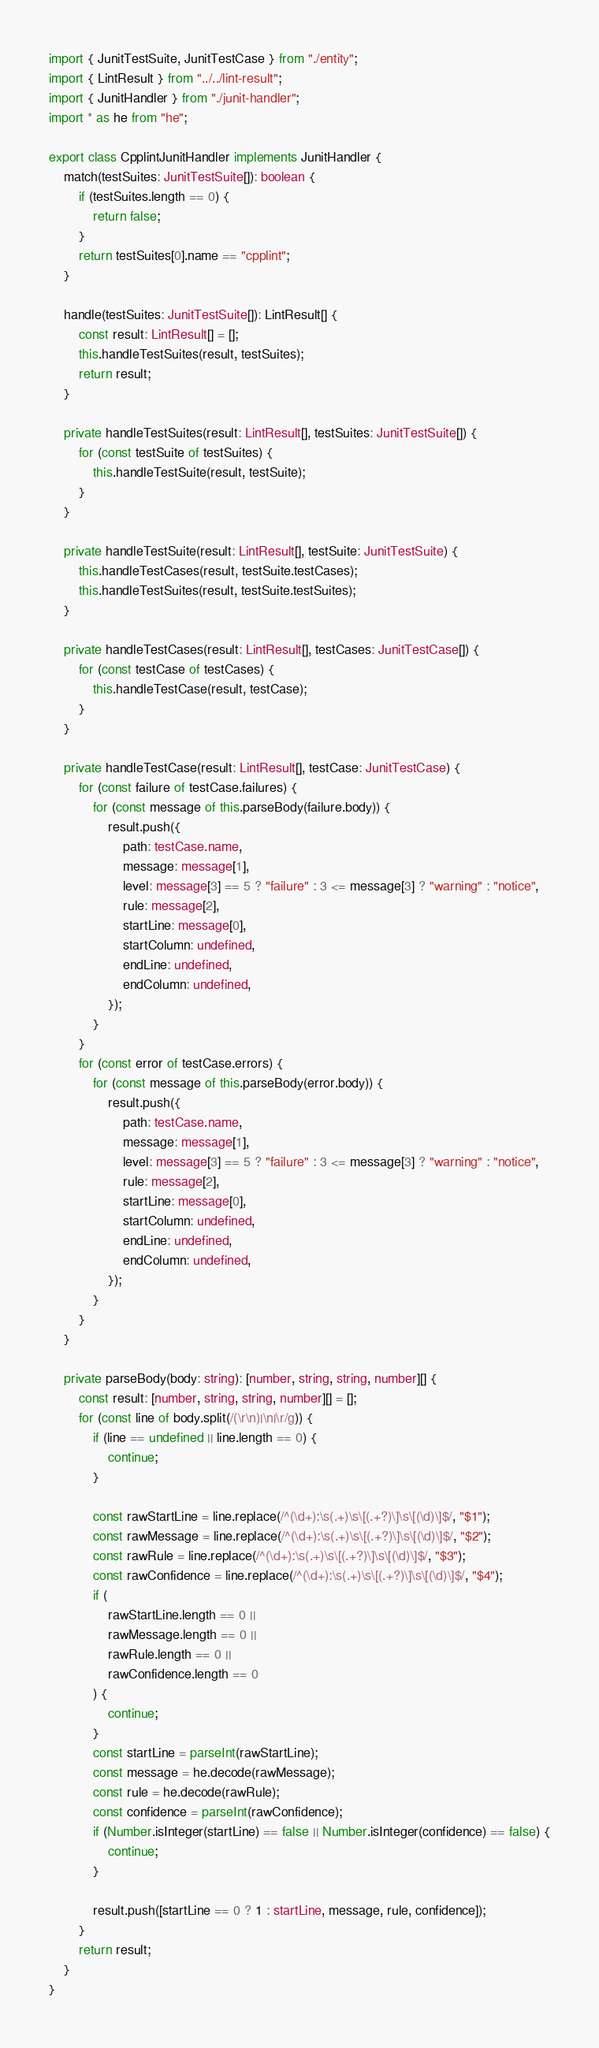Convert code to text. <code><loc_0><loc_0><loc_500><loc_500><_TypeScript_>import { JunitTestSuite, JunitTestCase } from "./entity";
import { LintResult } from "../../lint-result";
import { JunitHandler } from "./junit-handler";
import * as he from "he";

export class CpplintJunitHandler implements JunitHandler {
    match(testSuites: JunitTestSuite[]): boolean {
        if (testSuites.length == 0) {
            return false;
        }
        return testSuites[0].name == "cpplint";
    }

    handle(testSuites: JunitTestSuite[]): LintResult[] {
        const result: LintResult[] = [];
        this.handleTestSuites(result, testSuites);
        return result;
    }

    private handleTestSuites(result: LintResult[], testSuites: JunitTestSuite[]) {
        for (const testSuite of testSuites) {
            this.handleTestSuite(result, testSuite);
        }
    }

    private handleTestSuite(result: LintResult[], testSuite: JunitTestSuite) {
        this.handleTestCases(result, testSuite.testCases);
        this.handleTestSuites(result, testSuite.testSuites);
    }

    private handleTestCases(result: LintResult[], testCases: JunitTestCase[]) {
        for (const testCase of testCases) {
            this.handleTestCase(result, testCase);
        }
    }

    private handleTestCase(result: LintResult[], testCase: JunitTestCase) {
        for (const failure of testCase.failures) {
            for (const message of this.parseBody(failure.body)) {
                result.push({
                    path: testCase.name,
                    message: message[1],
                    level: message[3] == 5 ? "failure" : 3 <= message[3] ? "warning" : "notice",
                    rule: message[2],
                    startLine: message[0],
                    startColumn: undefined,
                    endLine: undefined,
                    endColumn: undefined,
                });
            }
        }
        for (const error of testCase.errors) {
            for (const message of this.parseBody(error.body)) {
                result.push({
                    path: testCase.name,
                    message: message[1],
                    level: message[3] == 5 ? "failure" : 3 <= message[3] ? "warning" : "notice",
                    rule: message[2],
                    startLine: message[0],
                    startColumn: undefined,
                    endLine: undefined,
                    endColumn: undefined,
                });
            }
        }
    }

    private parseBody(body: string): [number, string, string, number][] {
        const result: [number, string, string, number][] = [];
        for (const line of body.split(/(\r\n)|\n|\r/g)) {
            if (line == undefined || line.length == 0) {
                continue;
            }

            const rawStartLine = line.replace(/^(\d+):\s(.+)\s\[(.+?)\]\s\[(\d)\]$/, "$1");
            const rawMessage = line.replace(/^(\d+):\s(.+)\s\[(.+?)\]\s\[(\d)\]$/, "$2");
            const rawRule = line.replace(/^(\d+):\s(.+)\s\[(.+?)\]\s\[(\d)\]$/, "$3");
            const rawConfidence = line.replace(/^(\d+):\s(.+)\s\[(.+?)\]\s\[(\d)\]$/, "$4");
            if (
                rawStartLine.length == 0 ||
                rawMessage.length == 0 ||
                rawRule.length == 0 ||
                rawConfidence.length == 0
            ) {
                continue;
            }
            const startLine = parseInt(rawStartLine);
            const message = he.decode(rawMessage);
            const rule = he.decode(rawRule);
            const confidence = parseInt(rawConfidence);
            if (Number.isInteger(startLine) == false || Number.isInteger(confidence) == false) {
                continue;
            }

            result.push([startLine == 0 ? 1 : startLine, message, rule, confidence]);
        }
        return result;
    }
}
</code> 